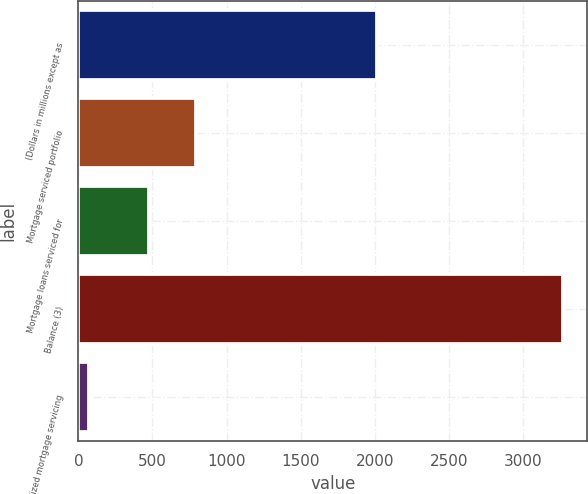Convert chart to OTSL. <chart><loc_0><loc_0><loc_500><loc_500><bar_chart><fcel>(Dollars in millions except as<fcel>Mortgage serviced portfolio<fcel>Mortgage loans serviced for<fcel>Balance (3)<fcel>Capitalized mortgage servicing<nl><fcel>2014<fcel>794.2<fcel>474<fcel>3271<fcel>69<nl></chart> 